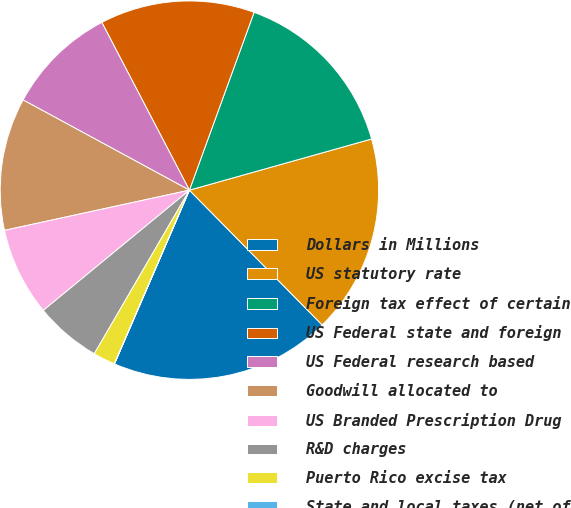<chart> <loc_0><loc_0><loc_500><loc_500><pie_chart><fcel>Dollars in Millions<fcel>US statutory rate<fcel>Foreign tax effect of certain<fcel>US Federal state and foreign<fcel>US Federal research based<fcel>Goodwill allocated to<fcel>US Branded Prescription Drug<fcel>R&D charges<fcel>Puerto Rico excise tax<fcel>State and local taxes (net of<nl><fcel>18.86%<fcel>16.98%<fcel>15.09%<fcel>13.21%<fcel>9.43%<fcel>11.32%<fcel>7.55%<fcel>5.66%<fcel>1.89%<fcel>0.01%<nl></chart> 